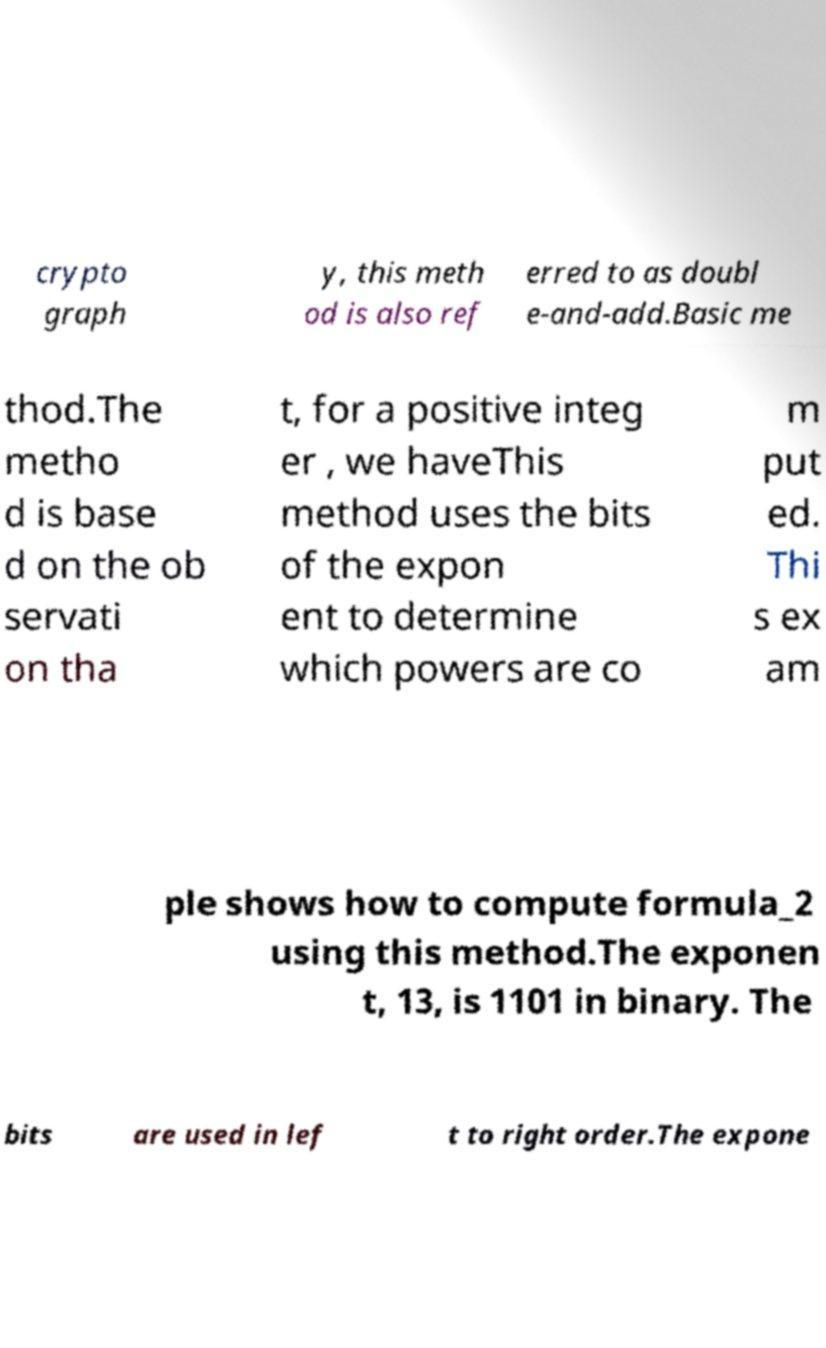For documentation purposes, I need the text within this image transcribed. Could you provide that? crypto graph y, this meth od is also ref erred to as doubl e-and-add.Basic me thod.The metho d is base d on the ob servati on tha t, for a positive integ er , we haveThis method uses the bits of the expon ent to determine which powers are co m put ed. Thi s ex am ple shows how to compute formula_2 using this method.The exponen t, 13, is 1101 in binary. The bits are used in lef t to right order.The expone 